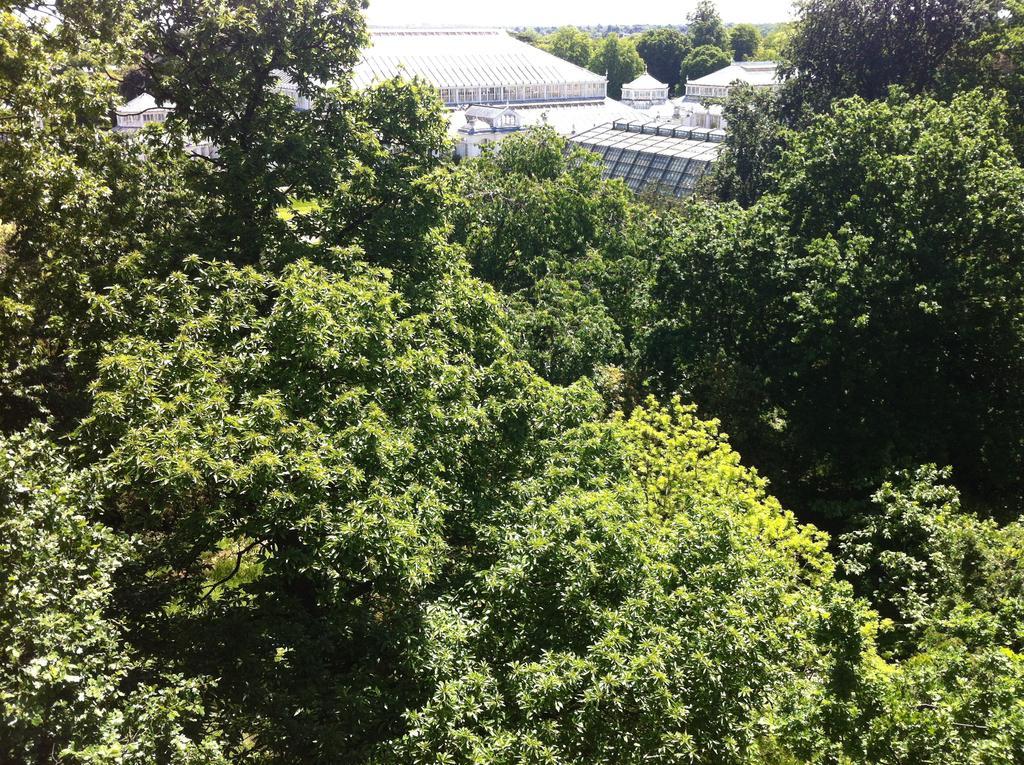How would you summarize this image in a sentence or two? At the bottom of the picture, we see the trees. There are trees and the buildings in the background. These buildings are in white color. 